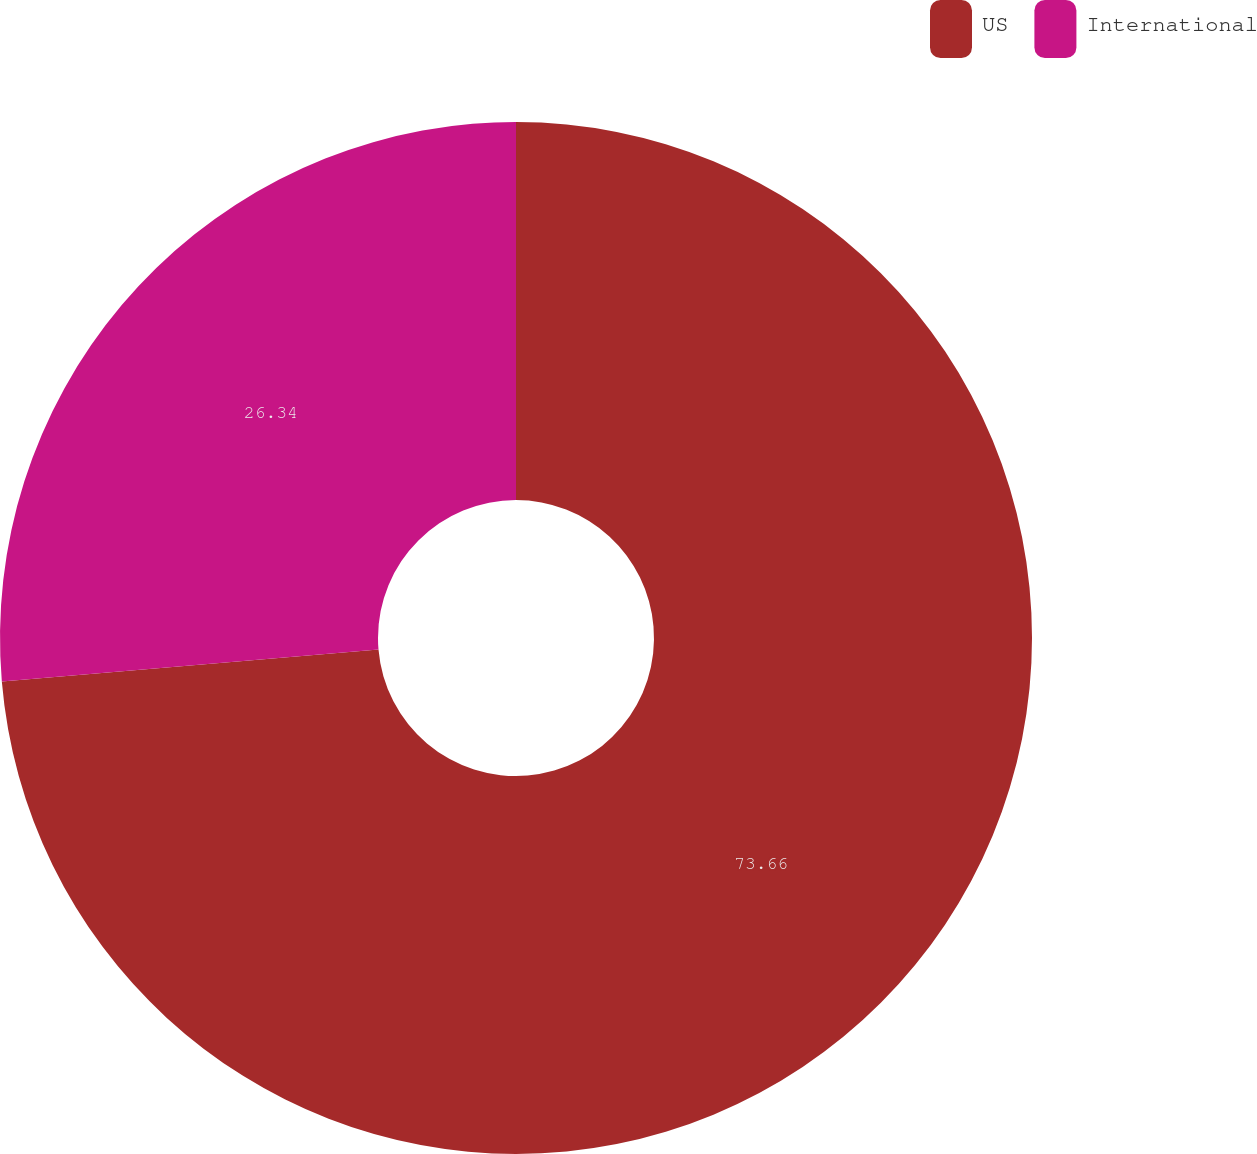Convert chart. <chart><loc_0><loc_0><loc_500><loc_500><pie_chart><fcel>US<fcel>International<nl><fcel>73.66%<fcel>26.34%<nl></chart> 